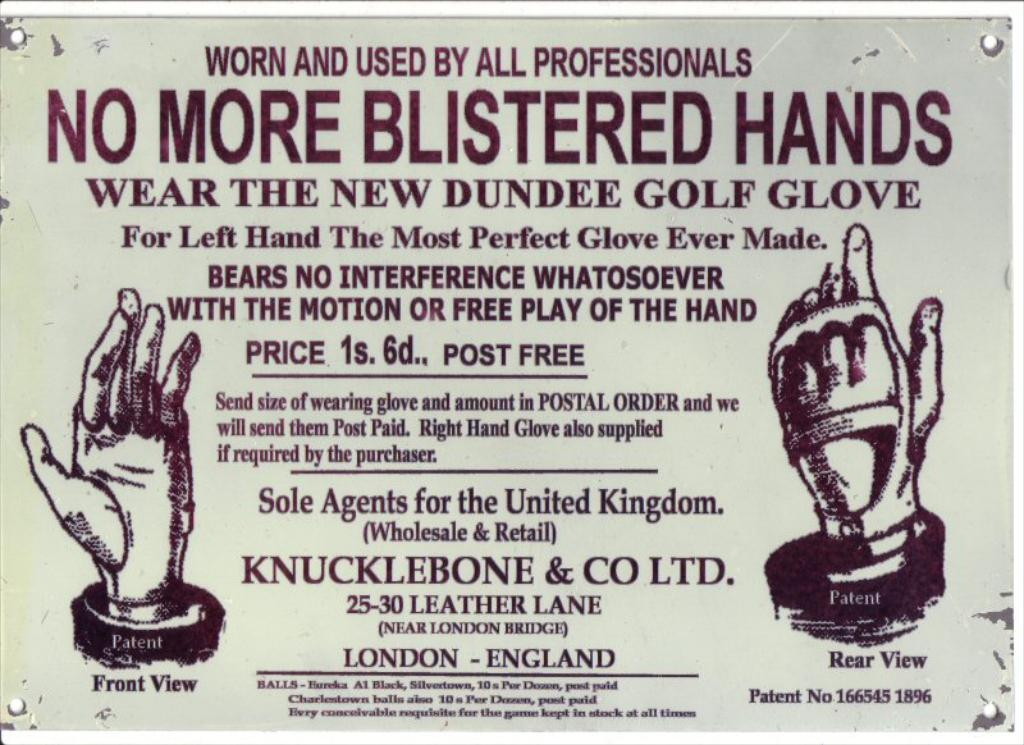<image>
Provide a brief description of the given image. A sign that says No More Blistered Hands 